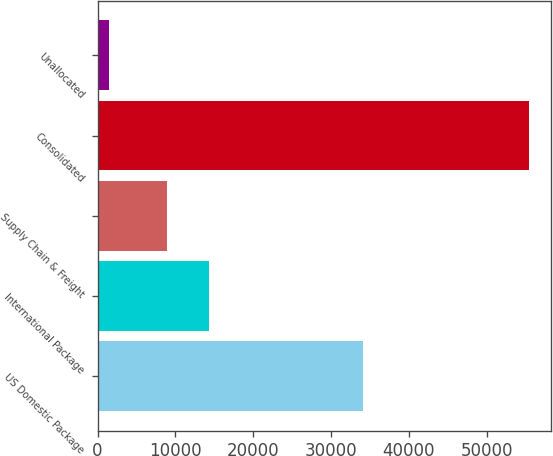Convert chart to OTSL. <chart><loc_0><loc_0><loc_500><loc_500><bar_chart><fcel>US Domestic Package<fcel>International Package<fcel>Supply Chain & Freight<fcel>Consolidated<fcel>Unallocated<nl><fcel>34074<fcel>14331.1<fcel>8935<fcel>55438<fcel>1477<nl></chart> 